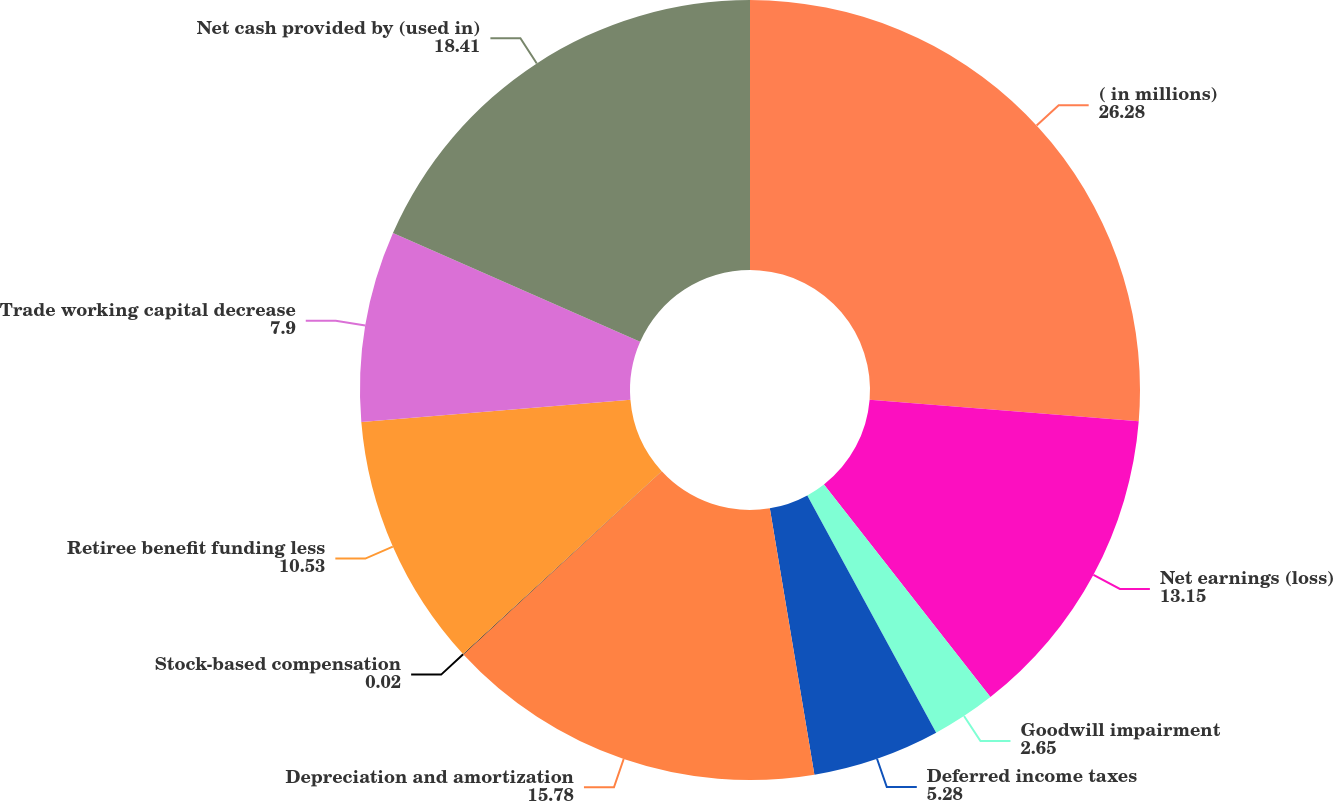Convert chart to OTSL. <chart><loc_0><loc_0><loc_500><loc_500><pie_chart><fcel>( in millions)<fcel>Net earnings (loss)<fcel>Goodwill impairment<fcel>Deferred income taxes<fcel>Depreciation and amortization<fcel>Stock-based compensation<fcel>Retiree benefit funding less<fcel>Trade working capital decrease<fcel>Net cash provided by (used in)<nl><fcel>26.28%<fcel>13.15%<fcel>2.65%<fcel>5.28%<fcel>15.78%<fcel>0.02%<fcel>10.53%<fcel>7.9%<fcel>18.41%<nl></chart> 